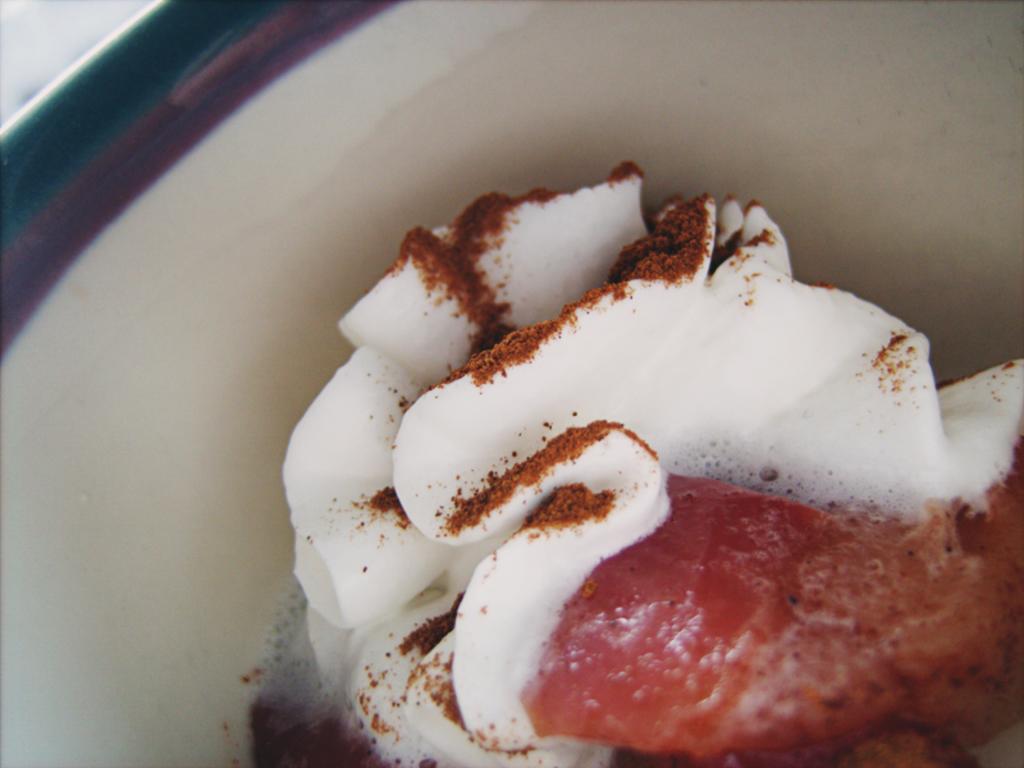In one or two sentences, can you explain what this image depicts? In the image there is a pastry in a bowl with cocoa powder on it. 